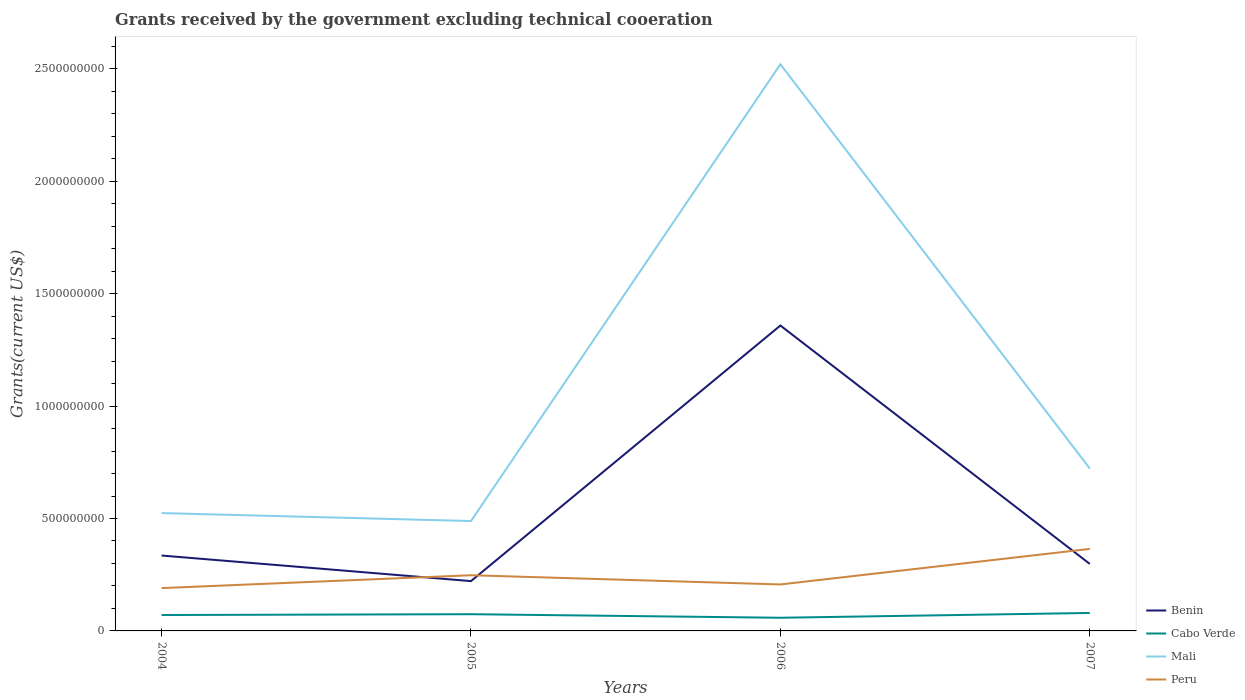Across all years, what is the maximum total grants received by the government in Cabo Verde?
Offer a terse response. 5.86e+07. In which year was the total grants received by the government in Benin maximum?
Ensure brevity in your answer.  2005. What is the total total grants received by the government in Peru in the graph?
Your response must be concise. -1.74e+08. What is the difference between the highest and the second highest total grants received by the government in Cabo Verde?
Offer a terse response. 2.13e+07. What is the difference between the highest and the lowest total grants received by the government in Peru?
Your answer should be compact. 1. Is the total grants received by the government in Mali strictly greater than the total grants received by the government in Benin over the years?
Offer a terse response. No. How many lines are there?
Keep it short and to the point. 4. How many years are there in the graph?
Offer a terse response. 4. What is the difference between two consecutive major ticks on the Y-axis?
Your response must be concise. 5.00e+08. Are the values on the major ticks of Y-axis written in scientific E-notation?
Offer a terse response. No. Does the graph contain any zero values?
Your answer should be very brief. No. Where does the legend appear in the graph?
Provide a short and direct response. Bottom right. How many legend labels are there?
Offer a terse response. 4. How are the legend labels stacked?
Provide a short and direct response. Vertical. What is the title of the graph?
Provide a short and direct response. Grants received by the government excluding technical cooeration. What is the label or title of the Y-axis?
Provide a short and direct response. Grants(current US$). What is the Grants(current US$) of Benin in 2004?
Ensure brevity in your answer.  3.35e+08. What is the Grants(current US$) of Cabo Verde in 2004?
Offer a terse response. 7.08e+07. What is the Grants(current US$) in Mali in 2004?
Offer a very short reply. 5.24e+08. What is the Grants(current US$) of Peru in 2004?
Keep it short and to the point. 1.90e+08. What is the Grants(current US$) of Benin in 2005?
Offer a terse response. 2.22e+08. What is the Grants(current US$) of Cabo Verde in 2005?
Offer a very short reply. 7.43e+07. What is the Grants(current US$) of Mali in 2005?
Offer a very short reply. 4.89e+08. What is the Grants(current US$) in Peru in 2005?
Your answer should be compact. 2.48e+08. What is the Grants(current US$) in Benin in 2006?
Your response must be concise. 1.36e+09. What is the Grants(current US$) in Cabo Verde in 2006?
Your response must be concise. 5.86e+07. What is the Grants(current US$) of Mali in 2006?
Provide a short and direct response. 2.52e+09. What is the Grants(current US$) in Peru in 2006?
Your answer should be very brief. 2.07e+08. What is the Grants(current US$) of Benin in 2007?
Provide a succinct answer. 2.98e+08. What is the Grants(current US$) in Cabo Verde in 2007?
Keep it short and to the point. 7.99e+07. What is the Grants(current US$) in Mali in 2007?
Offer a very short reply. 7.22e+08. What is the Grants(current US$) of Peru in 2007?
Provide a succinct answer. 3.65e+08. Across all years, what is the maximum Grants(current US$) in Benin?
Keep it short and to the point. 1.36e+09. Across all years, what is the maximum Grants(current US$) in Cabo Verde?
Your response must be concise. 7.99e+07. Across all years, what is the maximum Grants(current US$) of Mali?
Give a very brief answer. 2.52e+09. Across all years, what is the maximum Grants(current US$) of Peru?
Provide a succinct answer. 3.65e+08. Across all years, what is the minimum Grants(current US$) of Benin?
Offer a very short reply. 2.22e+08. Across all years, what is the minimum Grants(current US$) of Cabo Verde?
Your answer should be very brief. 5.86e+07. Across all years, what is the minimum Grants(current US$) of Mali?
Your response must be concise. 4.89e+08. Across all years, what is the minimum Grants(current US$) of Peru?
Provide a short and direct response. 1.90e+08. What is the total Grants(current US$) in Benin in the graph?
Provide a short and direct response. 2.21e+09. What is the total Grants(current US$) in Cabo Verde in the graph?
Offer a very short reply. 2.84e+08. What is the total Grants(current US$) of Mali in the graph?
Offer a very short reply. 4.26e+09. What is the total Grants(current US$) in Peru in the graph?
Make the answer very short. 1.01e+09. What is the difference between the Grants(current US$) of Benin in 2004 and that in 2005?
Make the answer very short. 1.14e+08. What is the difference between the Grants(current US$) in Cabo Verde in 2004 and that in 2005?
Provide a short and direct response. -3.55e+06. What is the difference between the Grants(current US$) in Mali in 2004 and that in 2005?
Your answer should be very brief. 3.54e+07. What is the difference between the Grants(current US$) in Peru in 2004 and that in 2005?
Your response must be concise. -5.72e+07. What is the difference between the Grants(current US$) in Benin in 2004 and that in 2006?
Make the answer very short. -1.02e+09. What is the difference between the Grants(current US$) of Cabo Verde in 2004 and that in 2006?
Provide a short and direct response. 1.22e+07. What is the difference between the Grants(current US$) of Mali in 2004 and that in 2006?
Offer a terse response. -2.00e+09. What is the difference between the Grants(current US$) of Peru in 2004 and that in 2006?
Provide a short and direct response. -1.62e+07. What is the difference between the Grants(current US$) of Benin in 2004 and that in 2007?
Give a very brief answer. 3.74e+07. What is the difference between the Grants(current US$) of Cabo Verde in 2004 and that in 2007?
Ensure brevity in your answer.  -9.12e+06. What is the difference between the Grants(current US$) of Mali in 2004 and that in 2007?
Provide a succinct answer. -1.98e+08. What is the difference between the Grants(current US$) in Peru in 2004 and that in 2007?
Offer a very short reply. -1.74e+08. What is the difference between the Grants(current US$) of Benin in 2005 and that in 2006?
Provide a short and direct response. -1.14e+09. What is the difference between the Grants(current US$) in Cabo Verde in 2005 and that in 2006?
Your answer should be very brief. 1.57e+07. What is the difference between the Grants(current US$) of Mali in 2005 and that in 2006?
Give a very brief answer. -2.03e+09. What is the difference between the Grants(current US$) of Peru in 2005 and that in 2006?
Ensure brevity in your answer.  4.10e+07. What is the difference between the Grants(current US$) of Benin in 2005 and that in 2007?
Offer a terse response. -7.64e+07. What is the difference between the Grants(current US$) of Cabo Verde in 2005 and that in 2007?
Give a very brief answer. -5.57e+06. What is the difference between the Grants(current US$) in Mali in 2005 and that in 2007?
Offer a terse response. -2.34e+08. What is the difference between the Grants(current US$) in Peru in 2005 and that in 2007?
Offer a terse response. -1.17e+08. What is the difference between the Grants(current US$) in Benin in 2006 and that in 2007?
Your response must be concise. 1.06e+09. What is the difference between the Grants(current US$) in Cabo Verde in 2006 and that in 2007?
Provide a succinct answer. -2.13e+07. What is the difference between the Grants(current US$) in Mali in 2006 and that in 2007?
Your answer should be compact. 1.80e+09. What is the difference between the Grants(current US$) in Peru in 2006 and that in 2007?
Offer a terse response. -1.58e+08. What is the difference between the Grants(current US$) in Benin in 2004 and the Grants(current US$) in Cabo Verde in 2005?
Your response must be concise. 2.61e+08. What is the difference between the Grants(current US$) of Benin in 2004 and the Grants(current US$) of Mali in 2005?
Offer a terse response. -1.53e+08. What is the difference between the Grants(current US$) of Benin in 2004 and the Grants(current US$) of Peru in 2005?
Ensure brevity in your answer.  8.77e+07. What is the difference between the Grants(current US$) of Cabo Verde in 2004 and the Grants(current US$) of Mali in 2005?
Provide a short and direct response. -4.18e+08. What is the difference between the Grants(current US$) in Cabo Verde in 2004 and the Grants(current US$) in Peru in 2005?
Your response must be concise. -1.77e+08. What is the difference between the Grants(current US$) of Mali in 2004 and the Grants(current US$) of Peru in 2005?
Your answer should be very brief. 2.76e+08. What is the difference between the Grants(current US$) of Benin in 2004 and the Grants(current US$) of Cabo Verde in 2006?
Give a very brief answer. 2.77e+08. What is the difference between the Grants(current US$) of Benin in 2004 and the Grants(current US$) of Mali in 2006?
Keep it short and to the point. -2.19e+09. What is the difference between the Grants(current US$) of Benin in 2004 and the Grants(current US$) of Peru in 2006?
Make the answer very short. 1.29e+08. What is the difference between the Grants(current US$) in Cabo Verde in 2004 and the Grants(current US$) in Mali in 2006?
Your response must be concise. -2.45e+09. What is the difference between the Grants(current US$) of Cabo Verde in 2004 and the Grants(current US$) of Peru in 2006?
Provide a succinct answer. -1.36e+08. What is the difference between the Grants(current US$) of Mali in 2004 and the Grants(current US$) of Peru in 2006?
Provide a succinct answer. 3.17e+08. What is the difference between the Grants(current US$) of Benin in 2004 and the Grants(current US$) of Cabo Verde in 2007?
Offer a very short reply. 2.55e+08. What is the difference between the Grants(current US$) in Benin in 2004 and the Grants(current US$) in Mali in 2007?
Keep it short and to the point. -3.87e+08. What is the difference between the Grants(current US$) in Benin in 2004 and the Grants(current US$) in Peru in 2007?
Make the answer very short. -2.94e+07. What is the difference between the Grants(current US$) of Cabo Verde in 2004 and the Grants(current US$) of Mali in 2007?
Your answer should be very brief. -6.52e+08. What is the difference between the Grants(current US$) in Cabo Verde in 2004 and the Grants(current US$) in Peru in 2007?
Make the answer very short. -2.94e+08. What is the difference between the Grants(current US$) of Mali in 2004 and the Grants(current US$) of Peru in 2007?
Provide a short and direct response. 1.59e+08. What is the difference between the Grants(current US$) in Benin in 2005 and the Grants(current US$) in Cabo Verde in 2006?
Provide a short and direct response. 1.63e+08. What is the difference between the Grants(current US$) in Benin in 2005 and the Grants(current US$) in Mali in 2006?
Your answer should be very brief. -2.30e+09. What is the difference between the Grants(current US$) in Benin in 2005 and the Grants(current US$) in Peru in 2006?
Your answer should be compact. 1.49e+07. What is the difference between the Grants(current US$) in Cabo Verde in 2005 and the Grants(current US$) in Mali in 2006?
Provide a succinct answer. -2.45e+09. What is the difference between the Grants(current US$) of Cabo Verde in 2005 and the Grants(current US$) of Peru in 2006?
Your answer should be compact. -1.32e+08. What is the difference between the Grants(current US$) in Mali in 2005 and the Grants(current US$) in Peru in 2006?
Provide a short and direct response. 2.82e+08. What is the difference between the Grants(current US$) in Benin in 2005 and the Grants(current US$) in Cabo Verde in 2007?
Offer a very short reply. 1.42e+08. What is the difference between the Grants(current US$) of Benin in 2005 and the Grants(current US$) of Mali in 2007?
Keep it short and to the point. -5.01e+08. What is the difference between the Grants(current US$) of Benin in 2005 and the Grants(current US$) of Peru in 2007?
Make the answer very short. -1.43e+08. What is the difference between the Grants(current US$) in Cabo Verde in 2005 and the Grants(current US$) in Mali in 2007?
Keep it short and to the point. -6.48e+08. What is the difference between the Grants(current US$) in Cabo Verde in 2005 and the Grants(current US$) in Peru in 2007?
Offer a very short reply. -2.90e+08. What is the difference between the Grants(current US$) in Mali in 2005 and the Grants(current US$) in Peru in 2007?
Your answer should be very brief. 1.24e+08. What is the difference between the Grants(current US$) of Benin in 2006 and the Grants(current US$) of Cabo Verde in 2007?
Offer a terse response. 1.28e+09. What is the difference between the Grants(current US$) of Benin in 2006 and the Grants(current US$) of Mali in 2007?
Your answer should be compact. 6.36e+08. What is the difference between the Grants(current US$) in Benin in 2006 and the Grants(current US$) in Peru in 2007?
Offer a very short reply. 9.94e+08. What is the difference between the Grants(current US$) in Cabo Verde in 2006 and the Grants(current US$) in Mali in 2007?
Ensure brevity in your answer.  -6.64e+08. What is the difference between the Grants(current US$) of Cabo Verde in 2006 and the Grants(current US$) of Peru in 2007?
Ensure brevity in your answer.  -3.06e+08. What is the difference between the Grants(current US$) in Mali in 2006 and the Grants(current US$) in Peru in 2007?
Make the answer very short. 2.16e+09. What is the average Grants(current US$) of Benin per year?
Make the answer very short. 5.53e+08. What is the average Grants(current US$) in Cabo Verde per year?
Your answer should be compact. 7.09e+07. What is the average Grants(current US$) of Mali per year?
Ensure brevity in your answer.  1.06e+09. What is the average Grants(current US$) of Peru per year?
Offer a very short reply. 2.52e+08. In the year 2004, what is the difference between the Grants(current US$) of Benin and Grants(current US$) of Cabo Verde?
Ensure brevity in your answer.  2.65e+08. In the year 2004, what is the difference between the Grants(current US$) of Benin and Grants(current US$) of Mali?
Your response must be concise. -1.89e+08. In the year 2004, what is the difference between the Grants(current US$) in Benin and Grants(current US$) in Peru?
Provide a short and direct response. 1.45e+08. In the year 2004, what is the difference between the Grants(current US$) in Cabo Verde and Grants(current US$) in Mali?
Give a very brief answer. -4.53e+08. In the year 2004, what is the difference between the Grants(current US$) in Cabo Verde and Grants(current US$) in Peru?
Offer a very short reply. -1.20e+08. In the year 2004, what is the difference between the Grants(current US$) in Mali and Grants(current US$) in Peru?
Provide a short and direct response. 3.34e+08. In the year 2005, what is the difference between the Grants(current US$) in Benin and Grants(current US$) in Cabo Verde?
Your answer should be very brief. 1.47e+08. In the year 2005, what is the difference between the Grants(current US$) of Benin and Grants(current US$) of Mali?
Ensure brevity in your answer.  -2.67e+08. In the year 2005, what is the difference between the Grants(current US$) in Benin and Grants(current US$) in Peru?
Give a very brief answer. -2.61e+07. In the year 2005, what is the difference between the Grants(current US$) of Cabo Verde and Grants(current US$) of Mali?
Keep it short and to the point. -4.14e+08. In the year 2005, what is the difference between the Grants(current US$) of Cabo Verde and Grants(current US$) of Peru?
Offer a terse response. -1.73e+08. In the year 2005, what is the difference between the Grants(current US$) of Mali and Grants(current US$) of Peru?
Ensure brevity in your answer.  2.41e+08. In the year 2006, what is the difference between the Grants(current US$) of Benin and Grants(current US$) of Cabo Verde?
Make the answer very short. 1.30e+09. In the year 2006, what is the difference between the Grants(current US$) in Benin and Grants(current US$) in Mali?
Make the answer very short. -1.16e+09. In the year 2006, what is the difference between the Grants(current US$) in Benin and Grants(current US$) in Peru?
Your response must be concise. 1.15e+09. In the year 2006, what is the difference between the Grants(current US$) in Cabo Verde and Grants(current US$) in Mali?
Your answer should be very brief. -2.46e+09. In the year 2006, what is the difference between the Grants(current US$) in Cabo Verde and Grants(current US$) in Peru?
Make the answer very short. -1.48e+08. In the year 2006, what is the difference between the Grants(current US$) in Mali and Grants(current US$) in Peru?
Offer a terse response. 2.31e+09. In the year 2007, what is the difference between the Grants(current US$) of Benin and Grants(current US$) of Cabo Verde?
Your response must be concise. 2.18e+08. In the year 2007, what is the difference between the Grants(current US$) of Benin and Grants(current US$) of Mali?
Provide a succinct answer. -4.24e+08. In the year 2007, what is the difference between the Grants(current US$) of Benin and Grants(current US$) of Peru?
Offer a terse response. -6.68e+07. In the year 2007, what is the difference between the Grants(current US$) in Cabo Verde and Grants(current US$) in Mali?
Your response must be concise. -6.42e+08. In the year 2007, what is the difference between the Grants(current US$) in Cabo Verde and Grants(current US$) in Peru?
Give a very brief answer. -2.85e+08. In the year 2007, what is the difference between the Grants(current US$) of Mali and Grants(current US$) of Peru?
Your answer should be compact. 3.58e+08. What is the ratio of the Grants(current US$) of Benin in 2004 to that in 2005?
Ensure brevity in your answer.  1.51. What is the ratio of the Grants(current US$) of Cabo Verde in 2004 to that in 2005?
Make the answer very short. 0.95. What is the ratio of the Grants(current US$) in Mali in 2004 to that in 2005?
Offer a terse response. 1.07. What is the ratio of the Grants(current US$) of Peru in 2004 to that in 2005?
Keep it short and to the point. 0.77. What is the ratio of the Grants(current US$) in Benin in 2004 to that in 2006?
Provide a succinct answer. 0.25. What is the ratio of the Grants(current US$) of Cabo Verde in 2004 to that in 2006?
Offer a terse response. 1.21. What is the ratio of the Grants(current US$) of Mali in 2004 to that in 2006?
Offer a very short reply. 0.21. What is the ratio of the Grants(current US$) in Peru in 2004 to that in 2006?
Offer a very short reply. 0.92. What is the ratio of the Grants(current US$) in Benin in 2004 to that in 2007?
Give a very brief answer. 1.13. What is the ratio of the Grants(current US$) in Cabo Verde in 2004 to that in 2007?
Your answer should be very brief. 0.89. What is the ratio of the Grants(current US$) of Mali in 2004 to that in 2007?
Keep it short and to the point. 0.73. What is the ratio of the Grants(current US$) of Peru in 2004 to that in 2007?
Your answer should be compact. 0.52. What is the ratio of the Grants(current US$) of Benin in 2005 to that in 2006?
Ensure brevity in your answer.  0.16. What is the ratio of the Grants(current US$) in Cabo Verde in 2005 to that in 2006?
Keep it short and to the point. 1.27. What is the ratio of the Grants(current US$) in Mali in 2005 to that in 2006?
Provide a short and direct response. 0.19. What is the ratio of the Grants(current US$) of Peru in 2005 to that in 2006?
Provide a succinct answer. 1.2. What is the ratio of the Grants(current US$) in Benin in 2005 to that in 2007?
Make the answer very short. 0.74. What is the ratio of the Grants(current US$) in Cabo Verde in 2005 to that in 2007?
Ensure brevity in your answer.  0.93. What is the ratio of the Grants(current US$) in Mali in 2005 to that in 2007?
Provide a succinct answer. 0.68. What is the ratio of the Grants(current US$) of Peru in 2005 to that in 2007?
Offer a terse response. 0.68. What is the ratio of the Grants(current US$) of Benin in 2006 to that in 2007?
Give a very brief answer. 4.56. What is the ratio of the Grants(current US$) of Cabo Verde in 2006 to that in 2007?
Ensure brevity in your answer.  0.73. What is the ratio of the Grants(current US$) of Mali in 2006 to that in 2007?
Provide a succinct answer. 3.49. What is the ratio of the Grants(current US$) in Peru in 2006 to that in 2007?
Keep it short and to the point. 0.57. What is the difference between the highest and the second highest Grants(current US$) of Benin?
Ensure brevity in your answer.  1.02e+09. What is the difference between the highest and the second highest Grants(current US$) in Cabo Verde?
Ensure brevity in your answer.  5.57e+06. What is the difference between the highest and the second highest Grants(current US$) of Mali?
Keep it short and to the point. 1.80e+09. What is the difference between the highest and the second highest Grants(current US$) of Peru?
Your answer should be compact. 1.17e+08. What is the difference between the highest and the lowest Grants(current US$) in Benin?
Give a very brief answer. 1.14e+09. What is the difference between the highest and the lowest Grants(current US$) of Cabo Verde?
Your answer should be compact. 2.13e+07. What is the difference between the highest and the lowest Grants(current US$) in Mali?
Offer a very short reply. 2.03e+09. What is the difference between the highest and the lowest Grants(current US$) in Peru?
Provide a succinct answer. 1.74e+08. 